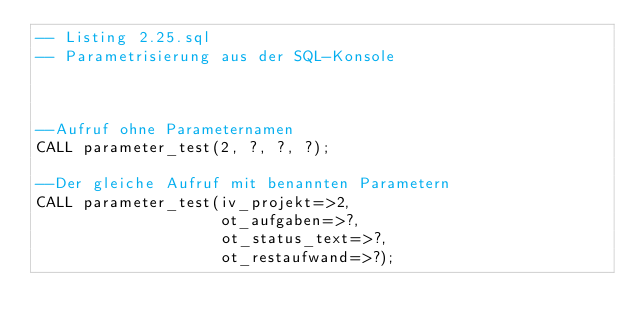Convert code to text. <code><loc_0><loc_0><loc_500><loc_500><_SQL_>-- Listing 2.25.sql
-- Parametrisierung aus der SQL-Konsole



--Aufruf ohne Parameternamen
CALL parameter_test(2, ?, ?, ?);

--Der gleiche Aufruf mit benannten Parametern
CALL parameter_test(iv_projekt=>2, 
                    ot_aufgaben=>?, 
                    ot_status_text=>?, 
                    ot_restaufwand=>?);
</code> 